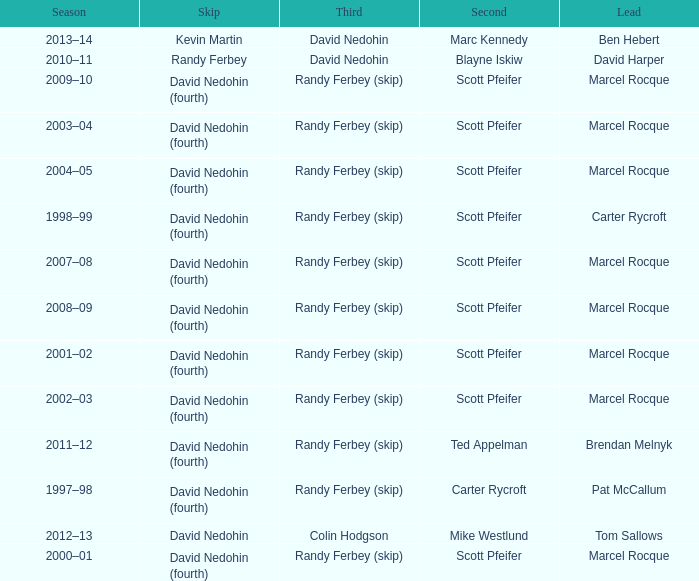Which Second has a Lead of ben hebert? Marc Kennedy. 